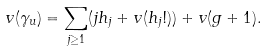<formula> <loc_0><loc_0><loc_500><loc_500>v ( \gamma _ { u } ) = \sum _ { j \geq 1 } ( j h _ { j } + v ( h _ { j } ! ) ) + v ( g + 1 ) .</formula> 